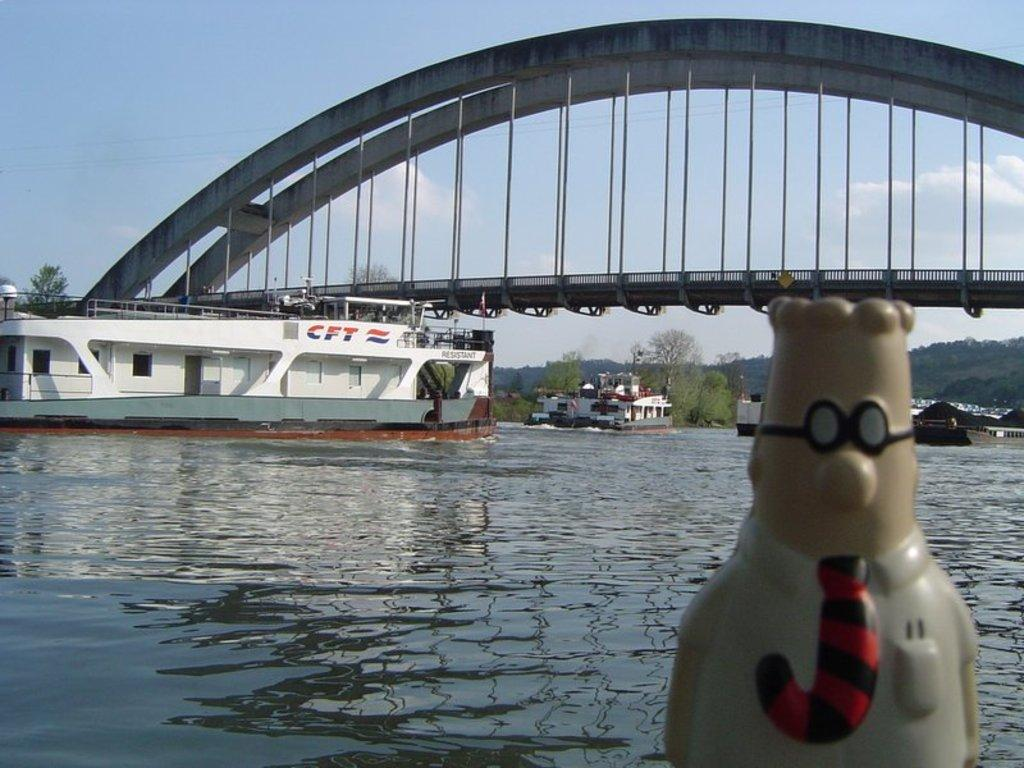What is the main subject of the image? There is a sculpture in the image. What can be seen in the water in the image? There are ships on the water in the image. What type of natural elements are visible in the background of the image? There are trees and clouds in the background of the image. What architectural feature can be seen in the background of the image? There is a bridge over the water in the background of the image. What type of gun is being used by the sculpture in the image? There is no gun present in the image; the main subject is a sculpture. 